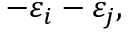Convert formula to latex. <formula><loc_0><loc_0><loc_500><loc_500>- \varepsilon _ { i } - \varepsilon _ { j } ,</formula> 